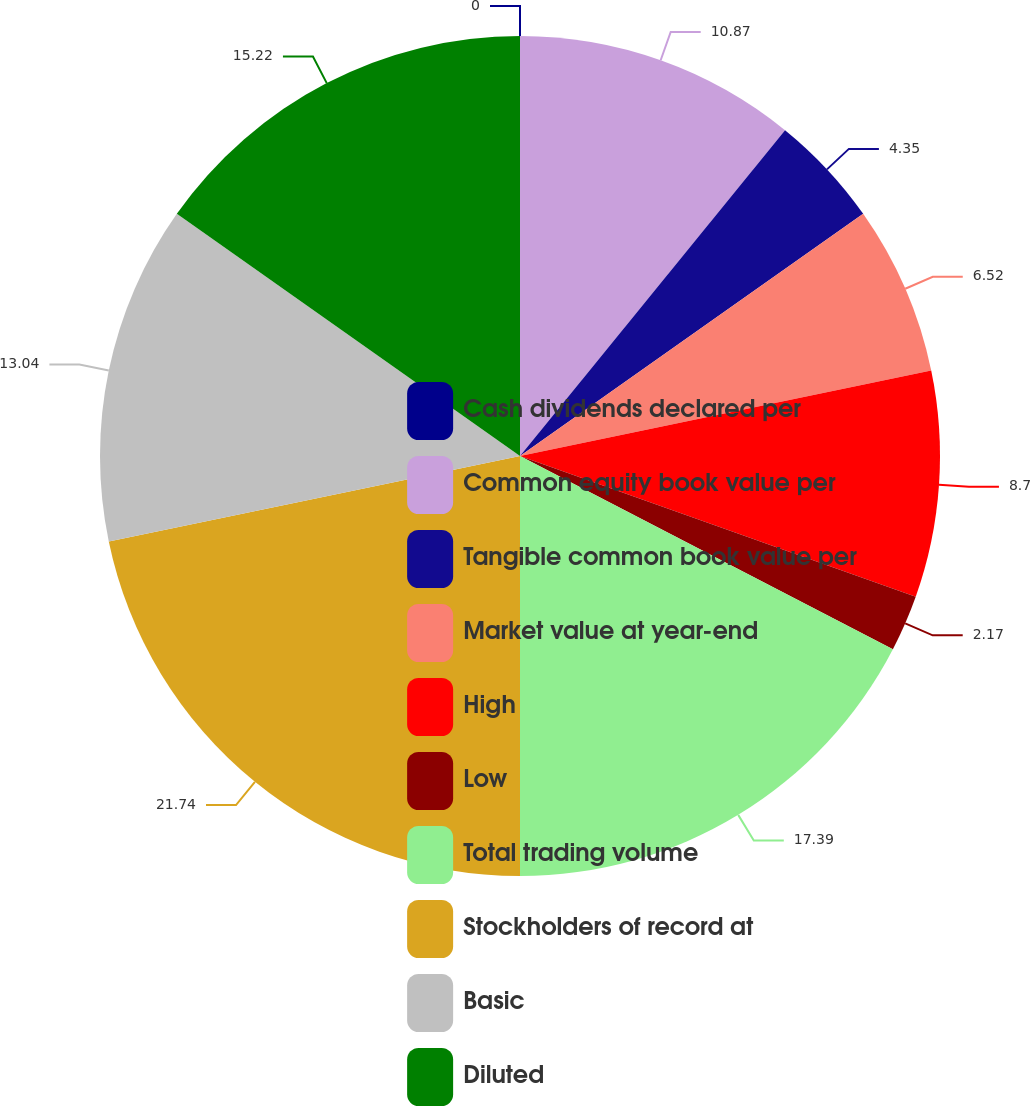Convert chart to OTSL. <chart><loc_0><loc_0><loc_500><loc_500><pie_chart><fcel>Cash dividends declared per<fcel>Common equity book value per<fcel>Tangible common book value per<fcel>Market value at year-end<fcel>High<fcel>Low<fcel>Total trading volume<fcel>Stockholders of record at<fcel>Basic<fcel>Diluted<nl><fcel>0.0%<fcel>10.87%<fcel>4.35%<fcel>6.52%<fcel>8.7%<fcel>2.17%<fcel>17.39%<fcel>21.74%<fcel>13.04%<fcel>15.22%<nl></chart> 